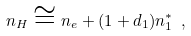Convert formula to latex. <formula><loc_0><loc_0><loc_500><loc_500>n _ { H } \cong n _ { e } + ( 1 + d _ { 1 } ) n _ { 1 } ^ { * } \ ,</formula> 